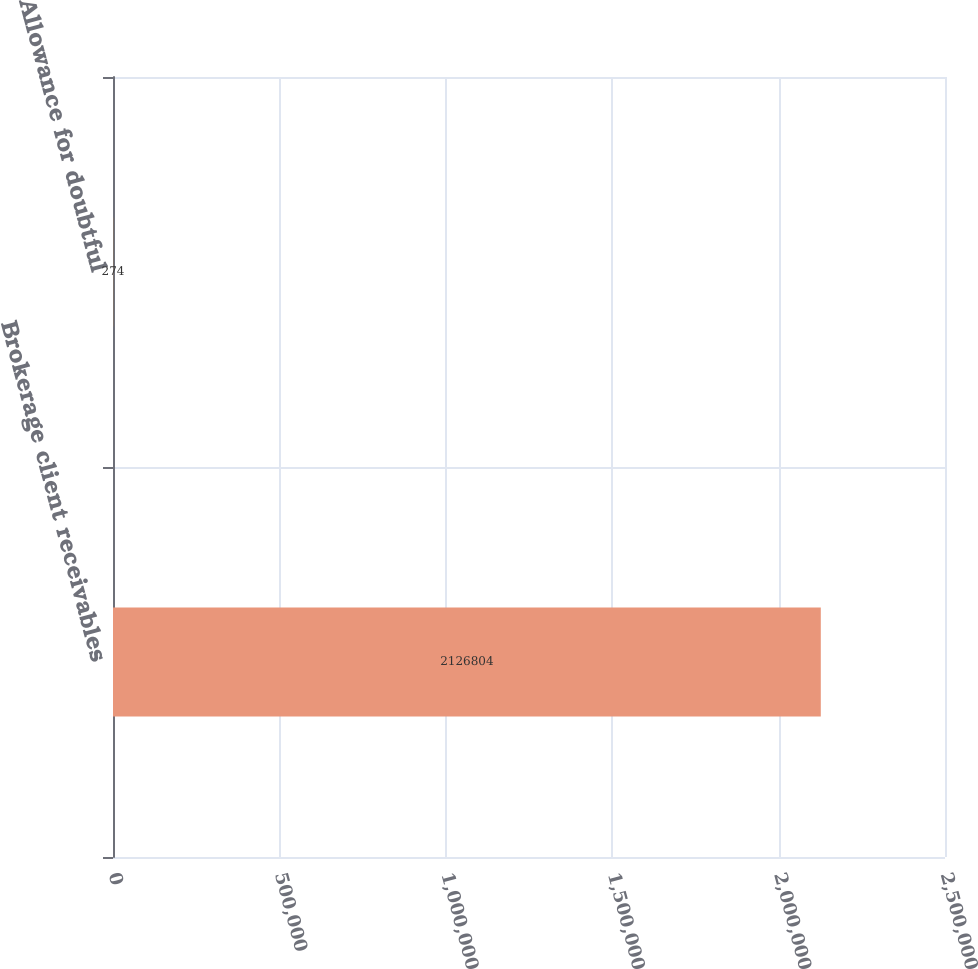<chart> <loc_0><loc_0><loc_500><loc_500><bar_chart><fcel>Brokerage client receivables<fcel>Allowance for doubtful<nl><fcel>2.1268e+06<fcel>274<nl></chart> 